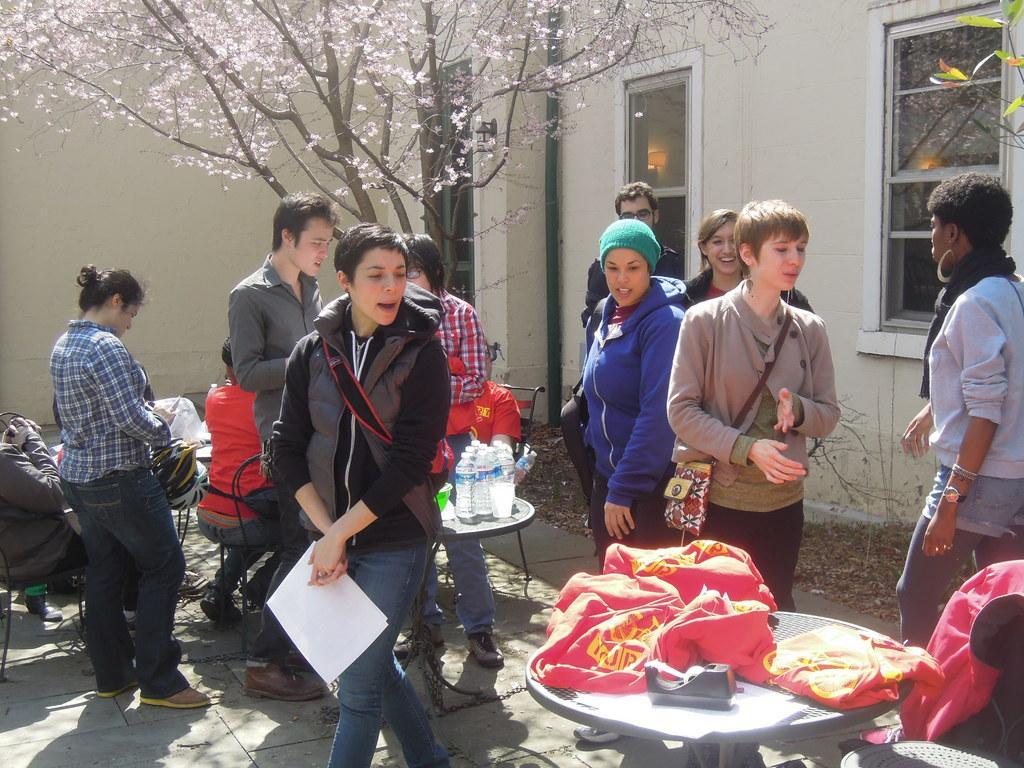How would you summarize this image in a sentence or two? In this image we can see a few people, some of them are sitting on the chairs, one of them is holding papers, there are bottles, clothes, and an object on the tables, there is a tree, a house, windows, there is a pipe. 